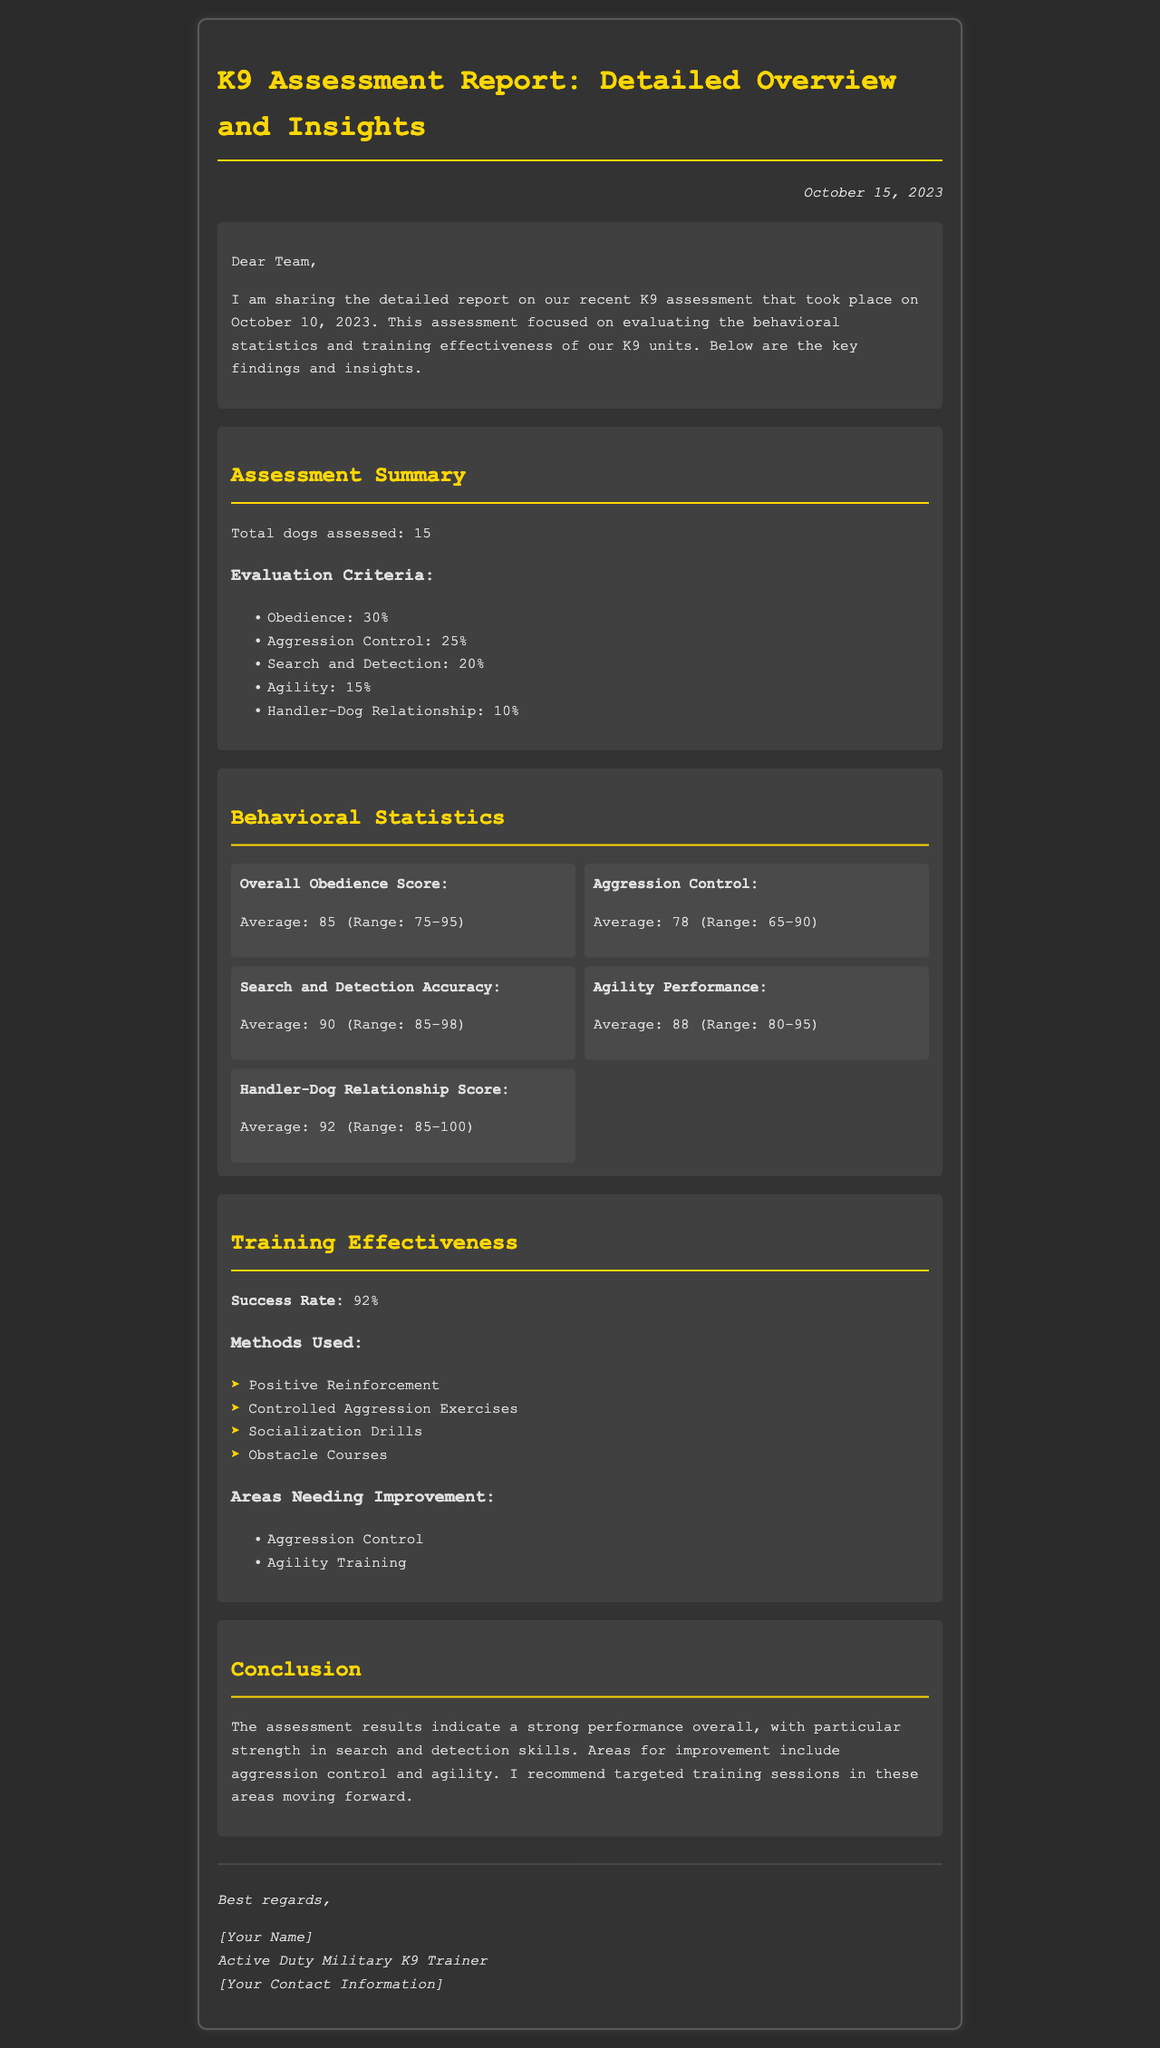What is the date of the K9 assessment? The date of the K9 assessment is mentioned in the document as October 10, 2023.
Answer: October 10, 2023 How many dogs were assessed? The document states that a total of 15 dogs were assessed during the evaluation.
Answer: 15 What was the average search and detection accuracy? The average search and detection accuracy is highlighted in the behavioral statistics section. The document notes it as 90.
Answer: 90 What is the success rate of the training? The success rate of the training is specifically mentioned in the training effectiveness section.
Answer: 92% What area needs improvement according to the assessment? The document lists areas needing improvement, with the first item being aggression control.
Answer: Aggression Control Which method was used for training? One of the methods used during the training is noted in the list under training effectiveness.
Answer: Positive Reinforcement What is the highest average score in behavioral statistics? The highest average score among the behavioral statistics is provided, which is 92 for the Handler-Dog Relationship Score.
Answer: 92 What is the title of the document? The title of the document is included at the beginning of the report.
Answer: K9 Assessment Report: Detailed Overview and Insights What criteria accounted for 30% of the evaluation? The document outlines specific criteria and states that obedience accounts for 30% of the evaluation.
Answer: Obedience 